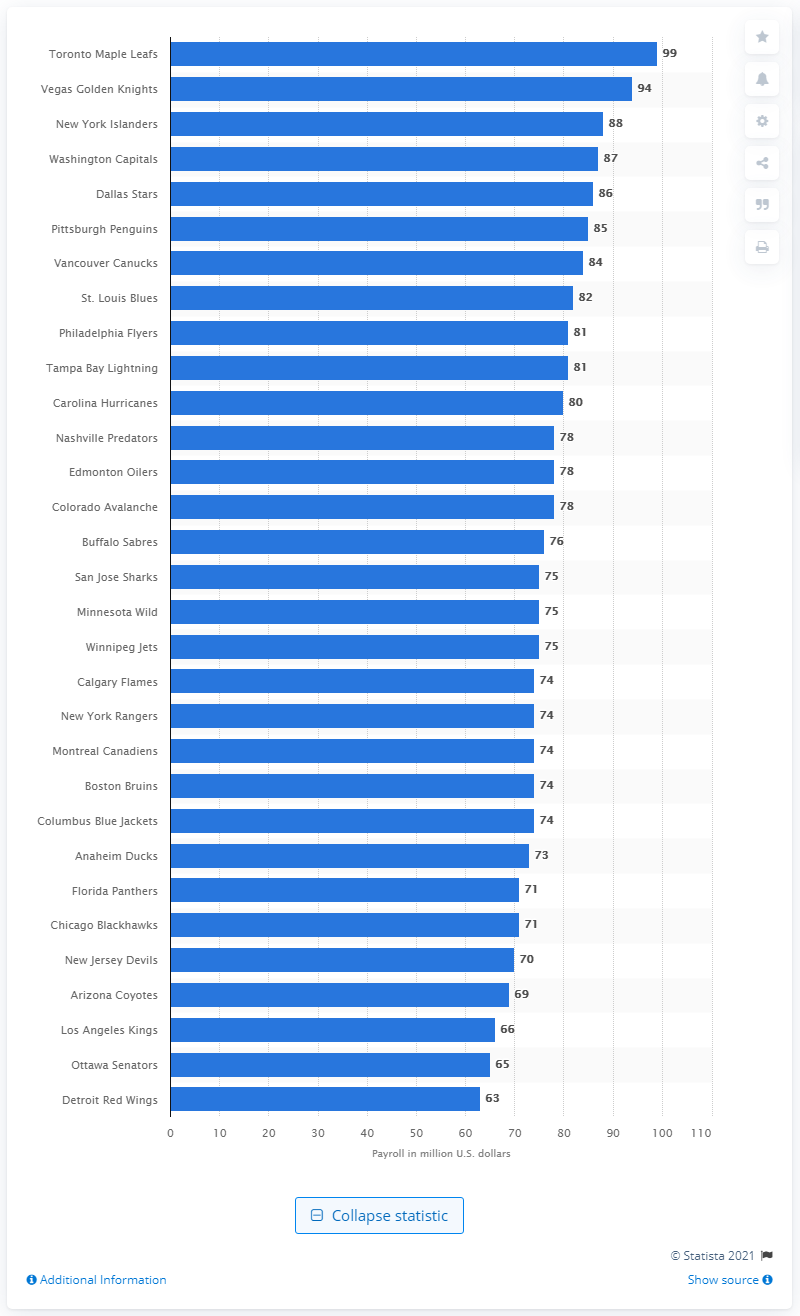Outline some significant characteristics in this image. The Philadelphia Flyers spent a total of $81 million on player salaries during the 2019/2020 season. 